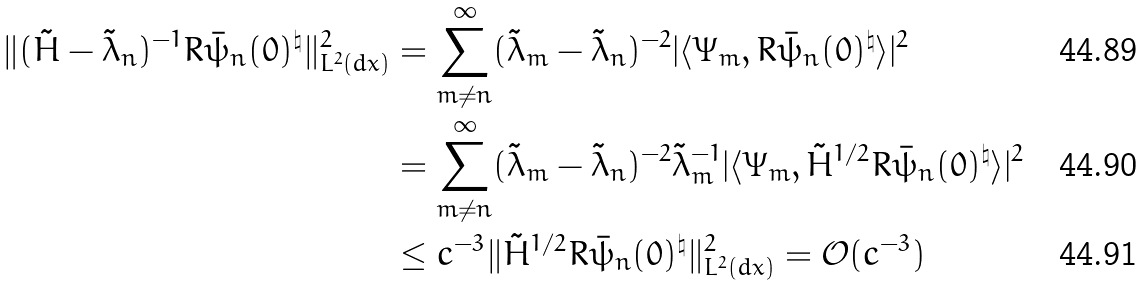Convert formula to latex. <formula><loc_0><loc_0><loc_500><loc_500>\| ( \tilde { H } - \tilde { \lambda } _ { n } ) ^ { - 1 } R \bar { \psi } _ { n } ( 0 ) ^ { \natural } \| _ { L ^ { 2 } ( d x ) } ^ { 2 } & = \sum _ { m \ne n } ^ { \infty } ( \tilde { \lambda } _ { m } - \tilde { \lambda } _ { n } ) ^ { - 2 } | \langle \Psi _ { m } , R \bar { \psi } _ { n } ( 0 ) ^ { \natural } \rangle | ^ { 2 } \\ & = \sum _ { m \ne n } ^ { \infty } ( \tilde { \lambda } _ { m } - \tilde { \lambda } _ { n } ) ^ { - 2 } \tilde { \lambda } _ { m } ^ { - 1 } | \langle \Psi _ { m } , \tilde { H } ^ { 1 / 2 } R \bar { \psi } _ { n } ( 0 ) ^ { \natural } \rangle | ^ { 2 } \\ & \leq c ^ { - 3 } \| \tilde { H } ^ { 1 / 2 } R \bar { \psi } _ { n } ( 0 ) ^ { \natural } \| _ { L ^ { 2 } ( d x ) } ^ { 2 } = \mathcal { O } ( c ^ { - 3 } )</formula> 